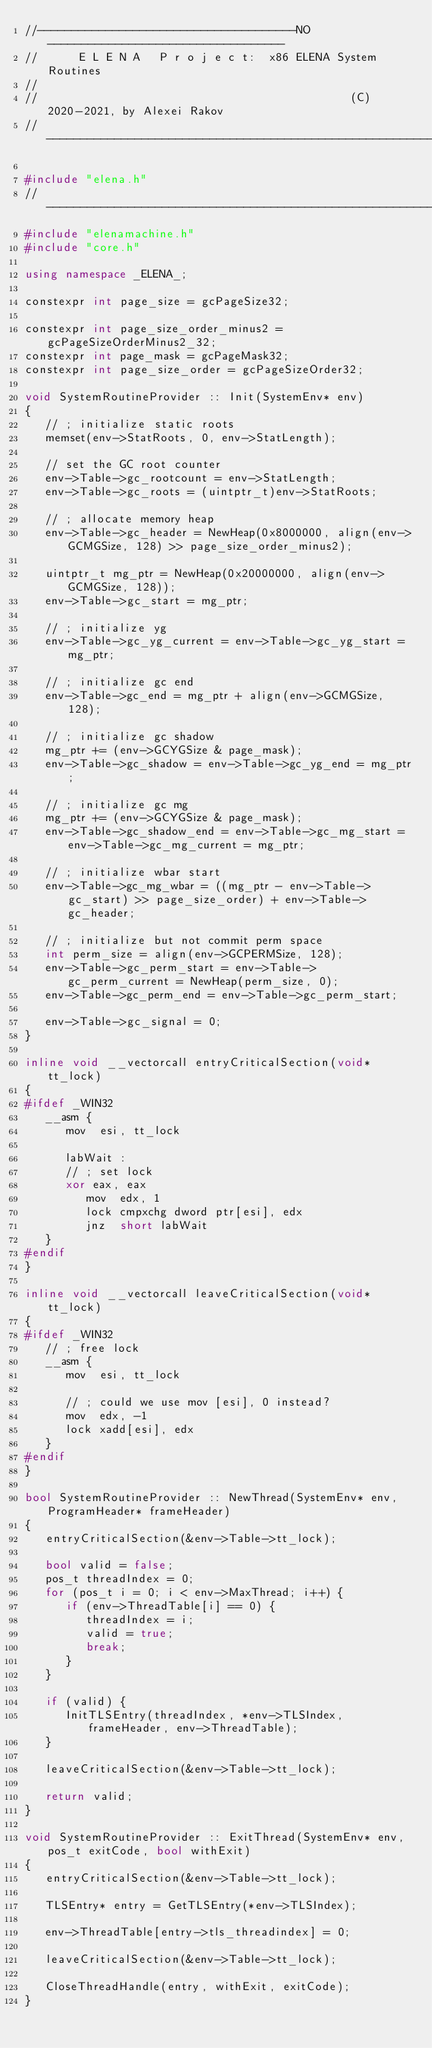<code> <loc_0><loc_0><loc_500><loc_500><_C++_>//--------------------------------------NO-----------------------------------
//		E L E N A   P r o j e c t:  x86 ELENA System Routines
//
//                                              (C)2020-2021, by Alexei Rakov
//---------------------------------------------------------------------------

#include "elena.h"
// --------------------------------------------------------------------------
#include "elenamachine.h"
#include "core.h"

using namespace _ELENA_;

constexpr int page_size = gcPageSize32;

constexpr int page_size_order_minus2 = gcPageSizeOrderMinus2_32;
constexpr int page_mask = gcPageMask32;
constexpr int page_size_order = gcPageSizeOrder32;

void SystemRoutineProvider :: Init(SystemEnv* env)
{
   // ; initialize static roots
   memset(env->StatRoots, 0, env->StatLength);

   // set the GC root counter
   env->Table->gc_rootcount = env->StatLength;
   env->Table->gc_roots = (uintptr_t)env->StatRoots;

   // ; allocate memory heap
   env->Table->gc_header = NewHeap(0x8000000, align(env->GCMGSize, 128) >> page_size_order_minus2);

   uintptr_t mg_ptr = NewHeap(0x20000000, align(env->GCMGSize, 128));
   env->Table->gc_start = mg_ptr;

   // ; initialize yg
   env->Table->gc_yg_current = env->Table->gc_yg_start = mg_ptr;

   // ; initialize gc end
   env->Table->gc_end = mg_ptr + align(env->GCMGSize, 128);

   // ; initialize gc shadow
   mg_ptr += (env->GCYGSize & page_mask);
   env->Table->gc_shadow = env->Table->gc_yg_end = mg_ptr;

   // ; initialize gc mg
   mg_ptr += (env->GCYGSize & page_mask);
   env->Table->gc_shadow_end = env->Table->gc_mg_start = env->Table->gc_mg_current = mg_ptr;

   // ; initialize wbar start
   env->Table->gc_mg_wbar = ((mg_ptr - env->Table->gc_start) >> page_size_order) + env->Table->gc_header;

   // ; initialize but not commit perm space
   int perm_size = align(env->GCPERMSize, 128);
   env->Table->gc_perm_start = env->Table->gc_perm_current = NewHeap(perm_size, 0);
   env->Table->gc_perm_end = env->Table->gc_perm_start;

   env->Table->gc_signal = 0;
}

inline void __vectorcall entryCriticalSection(void* tt_lock)
{
#ifdef _WIN32
   __asm {
      mov  esi, tt_lock

      labWait :
      // ; set lock
      xor eax, eax
         mov  edx, 1
         lock cmpxchg dword ptr[esi], edx
         jnz  short labWait
   }
#endif
}

inline void __vectorcall leaveCriticalSection(void* tt_lock)
{
#ifdef _WIN32
   // ; free lock
   __asm {
      mov  esi, tt_lock

      // ; could we use mov [esi], 0 instead?
      mov  edx, -1
      lock xadd[esi], edx
   }
#endif
}

bool SystemRoutineProvider :: NewThread(SystemEnv* env, ProgramHeader* frameHeader)
{
   entryCriticalSection(&env->Table->tt_lock);

   bool valid = false;
   pos_t threadIndex = 0;
   for (pos_t i = 0; i < env->MaxThread; i++) {
      if (env->ThreadTable[i] == 0) {
         threadIndex = i;
         valid = true;
         break;
      }
   }

   if (valid) {
      InitTLSEntry(threadIndex, *env->TLSIndex, frameHeader, env->ThreadTable);
   }

   leaveCriticalSection(&env->Table->tt_lock);

   return valid;
}

void SystemRoutineProvider :: ExitThread(SystemEnv* env, pos_t exitCode, bool withExit)
{
   entryCriticalSection(&env->Table->tt_lock);

   TLSEntry* entry = GetTLSEntry(*env->TLSIndex);

   env->ThreadTable[entry->tls_threadindex] = 0;

   leaveCriticalSection(&env->Table->tt_lock);

   CloseThreadHandle(entry, withExit, exitCode);
}


</code> 